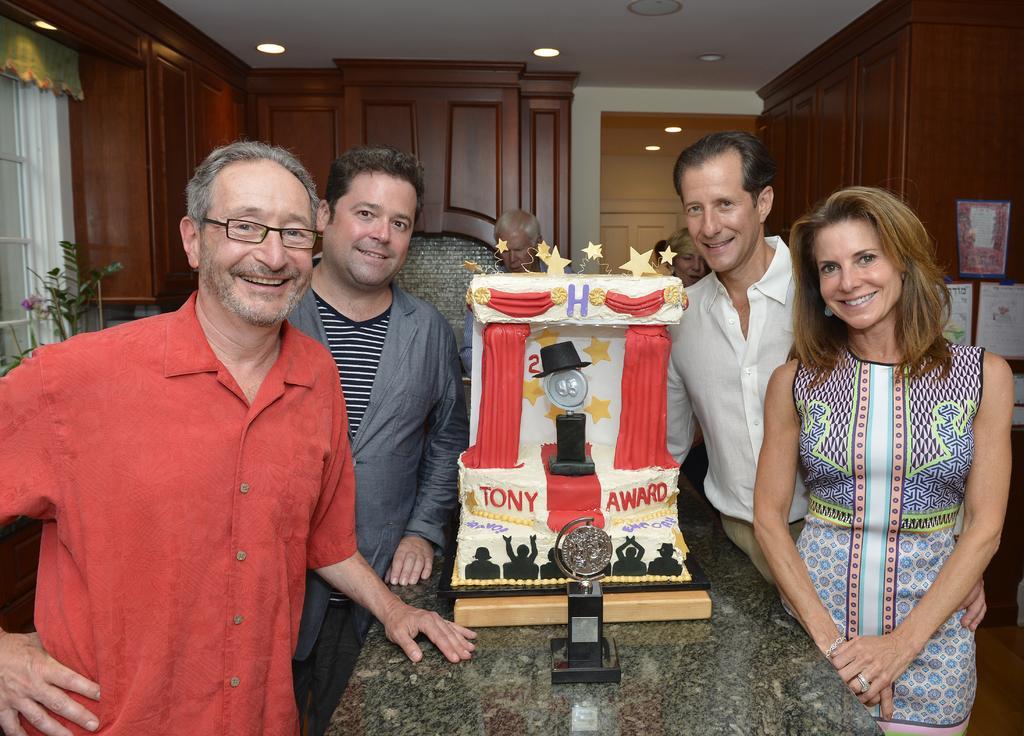In one or two sentences, can you explain what this image depicts? There is a cake kept on a table and around the table there are some people standing and posing for the photograph and all of them are smiling and behind these people there are many cupboards. 